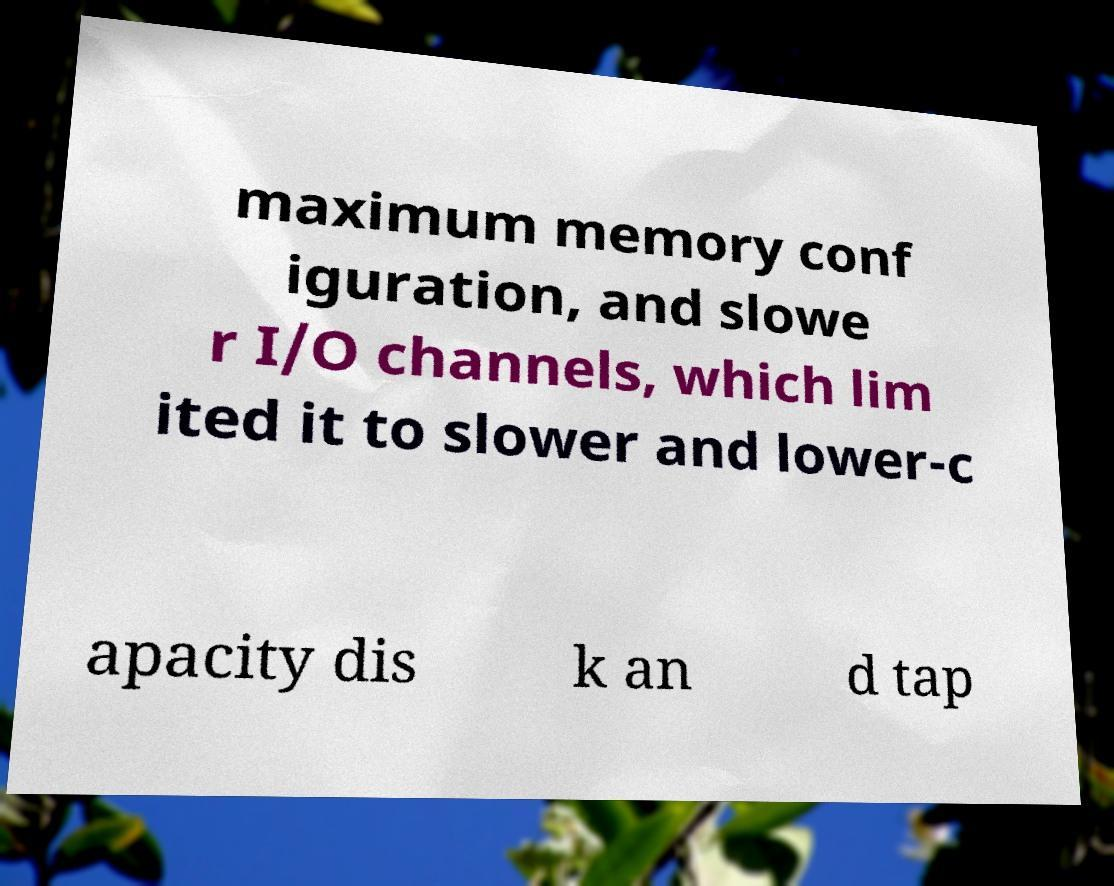I need the written content from this picture converted into text. Can you do that? maximum memory conf iguration, and slowe r I/O channels, which lim ited it to slower and lower-c apacity dis k an d tap 